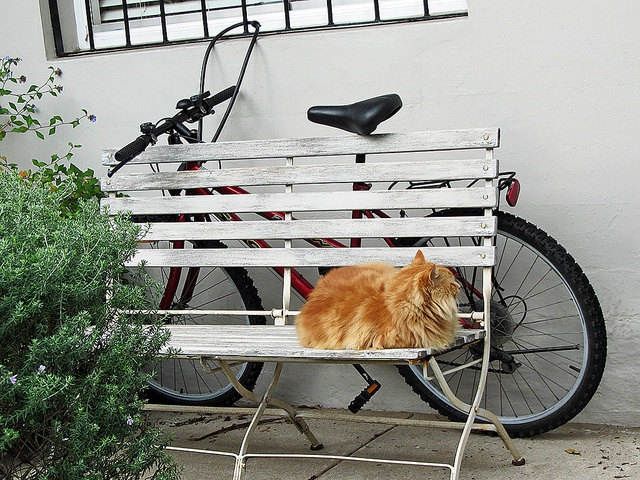Describe the objects in this image and their specific colors. I can see bench in lightgray, gray, black, and darkgray tones, bicycle in lightgray, black, gray, and darkgray tones, and cat in lightgray, red, and tan tones in this image. 